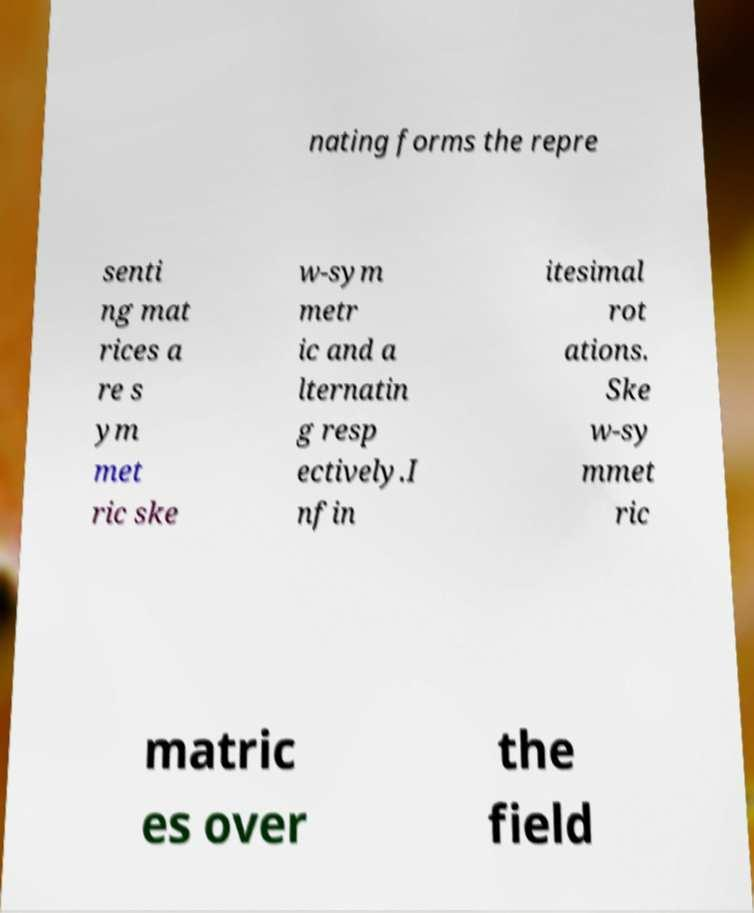What messages or text are displayed in this image? I need them in a readable, typed format. nating forms the repre senti ng mat rices a re s ym met ric ske w-sym metr ic and a lternatin g resp ectively.I nfin itesimal rot ations. Ske w-sy mmet ric matric es over the field 